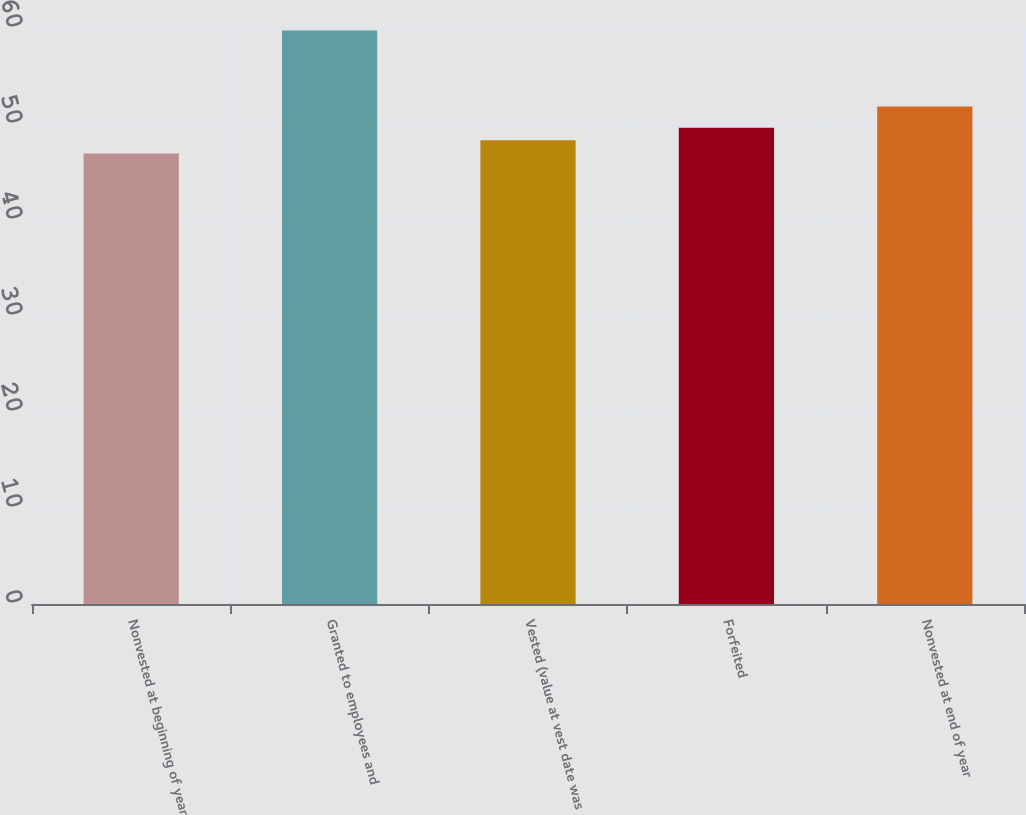Convert chart to OTSL. <chart><loc_0><loc_0><loc_500><loc_500><bar_chart><fcel>Nonvested at beginning of year<fcel>Granted to employees and<fcel>Vested (value at vest date was<fcel>Forfeited<fcel>Nonvested at end of year<nl><fcel>46.92<fcel>59.75<fcel>48.32<fcel>49.6<fcel>51.83<nl></chart> 